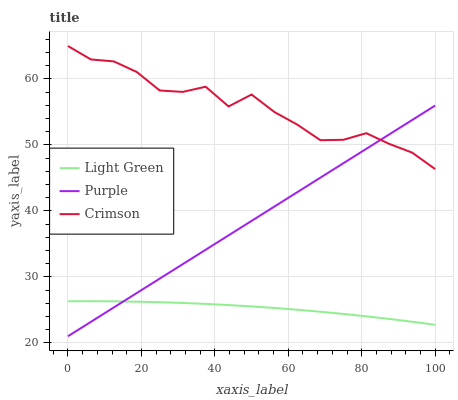Does Light Green have the minimum area under the curve?
Answer yes or no. Yes. Does Crimson have the maximum area under the curve?
Answer yes or no. Yes. Does Crimson have the minimum area under the curve?
Answer yes or no. No. Does Light Green have the maximum area under the curve?
Answer yes or no. No. Is Purple the smoothest?
Answer yes or no. Yes. Is Crimson the roughest?
Answer yes or no. Yes. Is Light Green the smoothest?
Answer yes or no. No. Is Light Green the roughest?
Answer yes or no. No. Does Purple have the lowest value?
Answer yes or no. Yes. Does Light Green have the lowest value?
Answer yes or no. No. Does Crimson have the highest value?
Answer yes or no. Yes. Does Light Green have the highest value?
Answer yes or no. No. Is Light Green less than Crimson?
Answer yes or no. Yes. Is Crimson greater than Light Green?
Answer yes or no. Yes. Does Light Green intersect Purple?
Answer yes or no. Yes. Is Light Green less than Purple?
Answer yes or no. No. Is Light Green greater than Purple?
Answer yes or no. No. Does Light Green intersect Crimson?
Answer yes or no. No. 